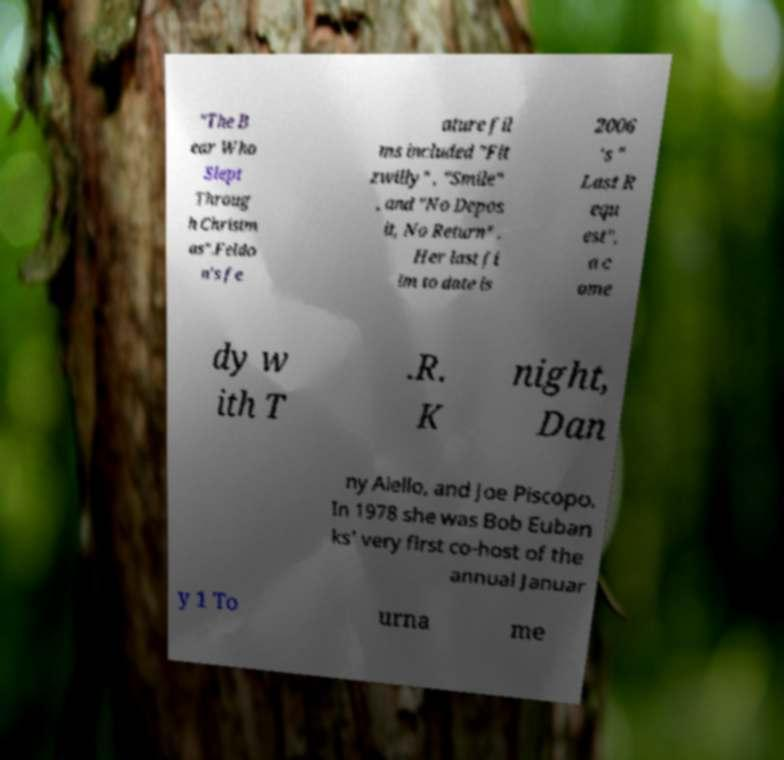Can you read and provide the text displayed in the image?This photo seems to have some interesting text. Can you extract and type it out for me? "The B ear Who Slept Throug h Christm as".Feldo n's fe ature fil ms included "Fit zwilly" , "Smile" , and "No Depos it, No Return" . Her last fi lm to date is 2006 's " Last R equ est", a c ome dy w ith T .R. K night, Dan ny Aiello, and Joe Piscopo. In 1978 she was Bob Euban ks' very first co-host of the annual Januar y 1 To urna me 